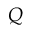Convert formula to latex. <formula><loc_0><loc_0><loc_500><loc_500>Q</formula> 